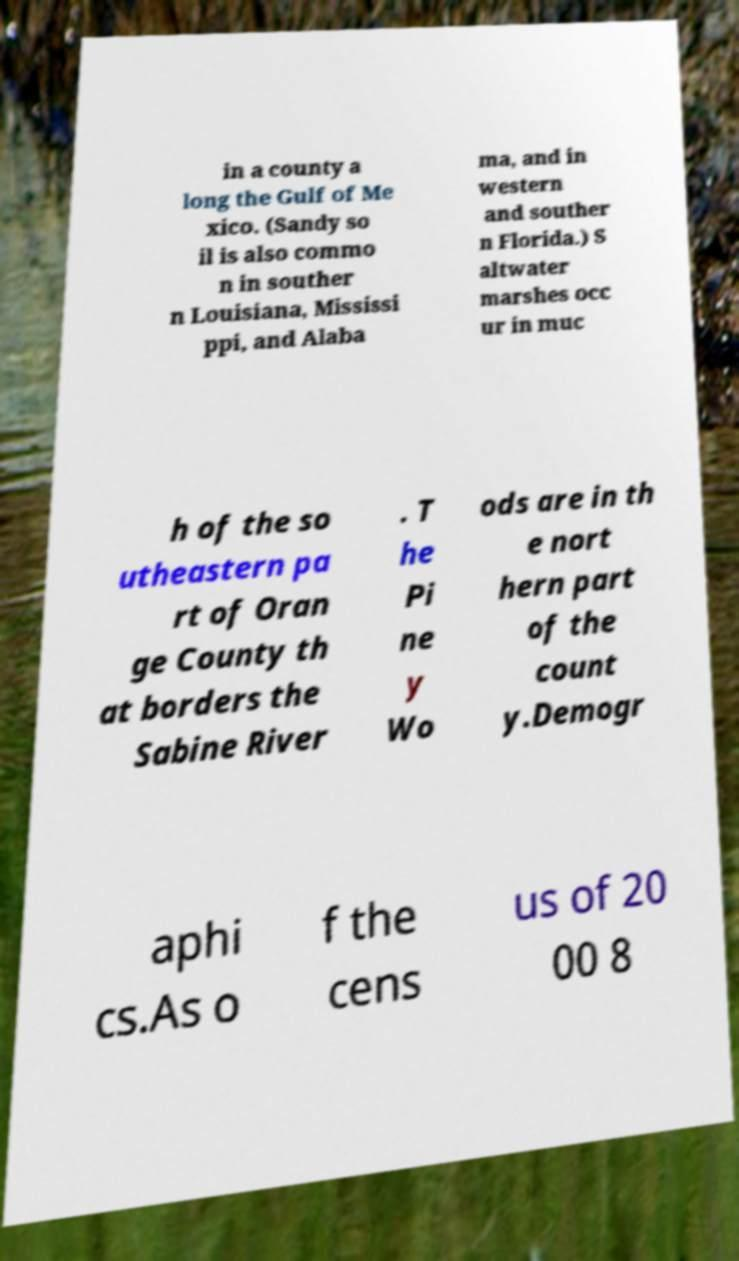I need the written content from this picture converted into text. Can you do that? in a county a long the Gulf of Me xico. (Sandy so il is also commo n in souther n Louisiana, Mississi ppi, and Alaba ma, and in western and souther n Florida.) S altwater marshes occ ur in muc h of the so utheastern pa rt of Oran ge County th at borders the Sabine River . T he Pi ne y Wo ods are in th e nort hern part of the count y.Demogr aphi cs.As o f the cens us of 20 00 8 